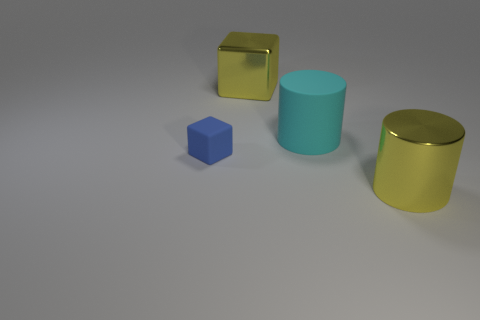Add 3 yellow shiny cylinders. How many objects exist? 7 Subtract all matte things. Subtract all metallic things. How many objects are left? 0 Add 2 metallic blocks. How many metallic blocks are left? 3 Add 2 large cyan objects. How many large cyan objects exist? 3 Subtract 0 green blocks. How many objects are left? 4 